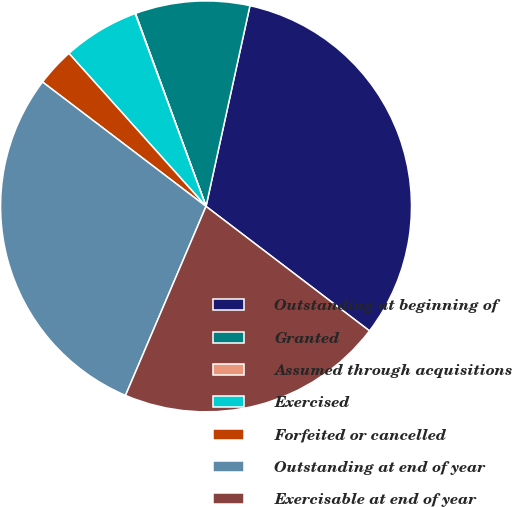Convert chart to OTSL. <chart><loc_0><loc_0><loc_500><loc_500><pie_chart><fcel>Outstanding at beginning of<fcel>Granted<fcel>Assumed through acquisitions<fcel>Exercised<fcel>Forfeited or cancelled<fcel>Outstanding at end of year<fcel>Exercisable at end of year<nl><fcel>31.93%<fcel>9.01%<fcel>0.03%<fcel>6.02%<fcel>3.02%<fcel>28.94%<fcel>21.05%<nl></chart> 